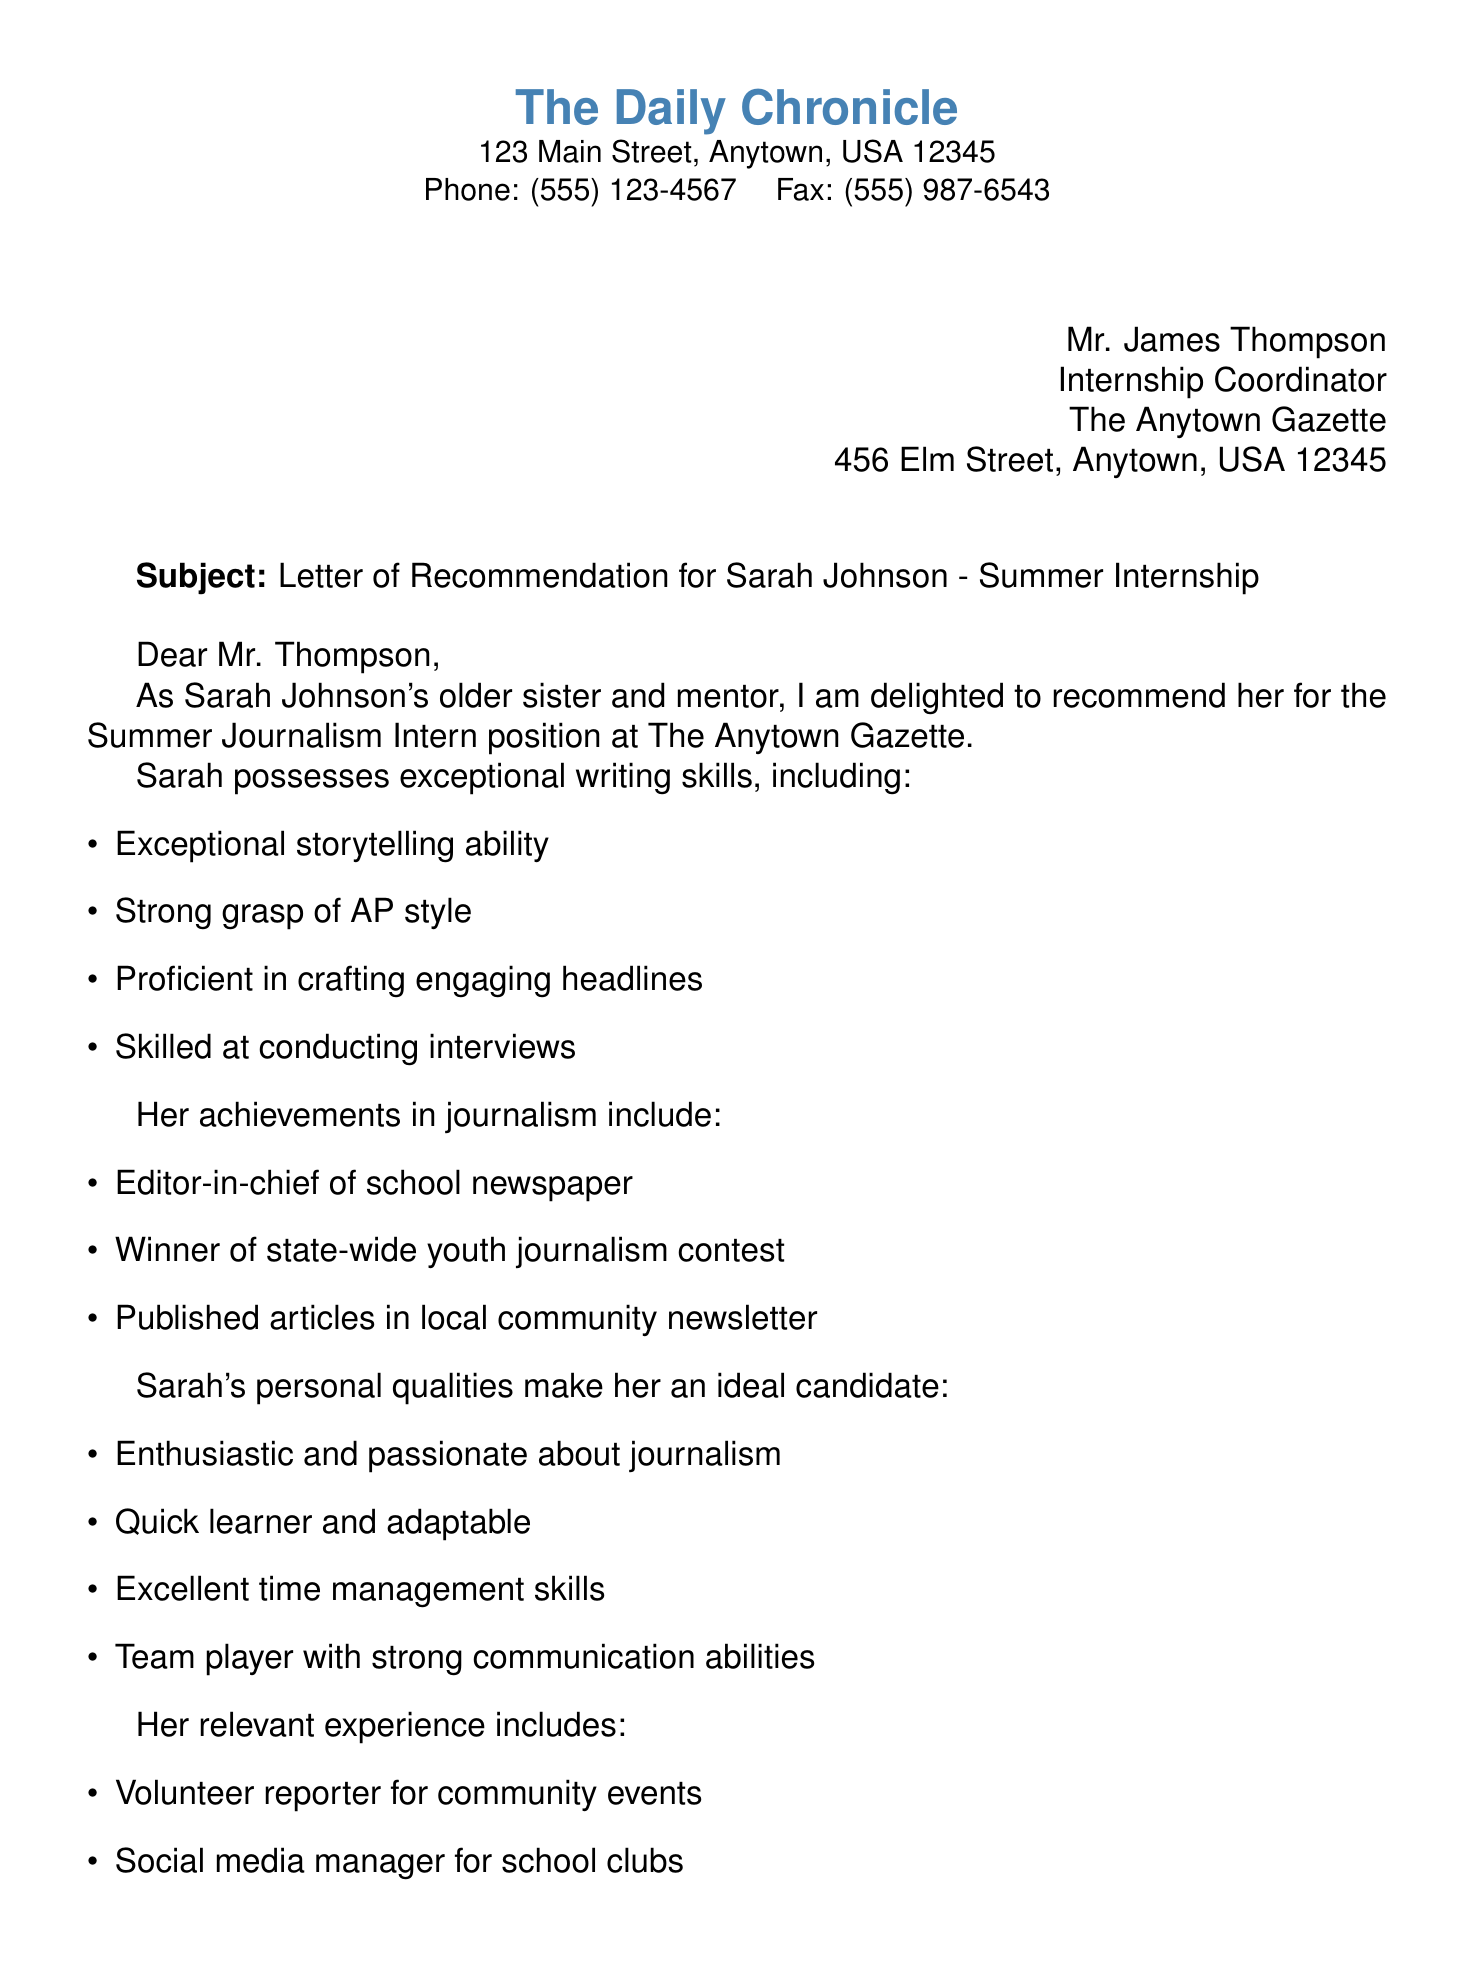What is the subject of the letter? The subject line clearly states what the letter is about, which is the recommendation for the internship.
Answer: Letter of Recommendation for Sarah Johnson - Summer Internship Who is the recipient of the fax? The document specifies the person to whom the fax is addressed at the top right corner.
Answer: Mr. James Thompson What position is Sarah applying for? The letter mentions the specific internship Sarah is applying for in the subject line.
Answer: Summer Journalism Intern List one of Sarah's achievements in journalism. The document includes several of Sarah's accomplishments listed in a bullet format.
Answer: Editor-in-chief of school newspaper What quality of Sarah is highlighted in the letter? The letter outlines several personal qualities of Sarah that make her suitable for the position.
Answer: Enthusiastic and passionate about journalism How many bullet points list Sarah's writing skills? The letter includes a list outlining Sarah's writing skills, which can be counted.
Answer: Four What is the name of the sender? The author's name and title are provided at the end of the letter.
Answer: Emily Johnson What is the sender's profession? The sender's occupation is mentioned right below her name at the end of the document.
Answer: Freelance Journalist 